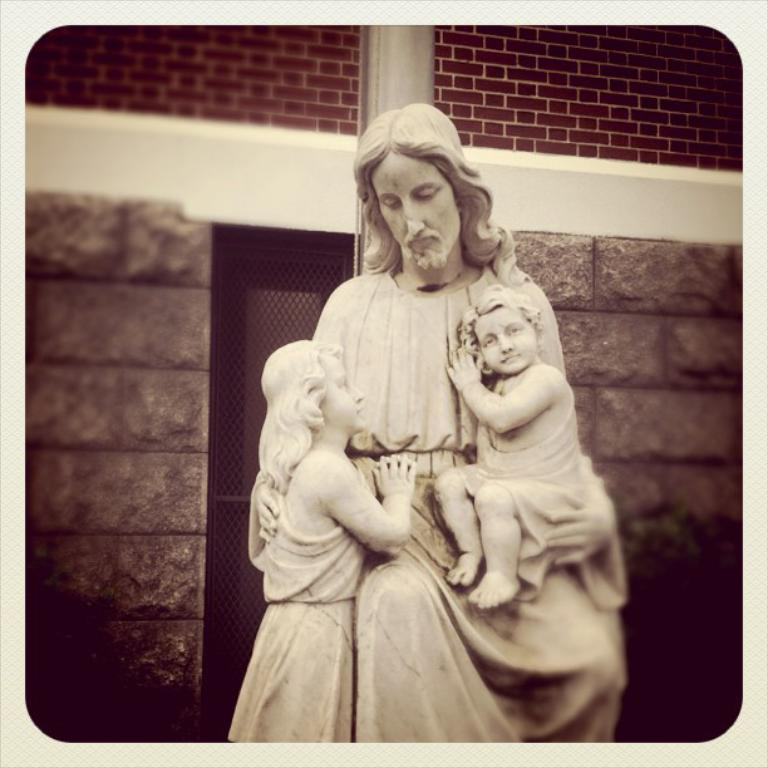What type of sculpture can be seen in the image? There is a sculpture of a person in the image. How many children's sculptures are present in the image? There are two children's sculptures in the image. What type of structure can be seen in the background of the image? There is a brick wall in the image. What type of material is present in the image? There is a mesh in the image. What type of soup is being served in the image? There is no soup present in the image. What process is being depicted in the image? The image does not depict a process; it features sculptures and a brick wall. 